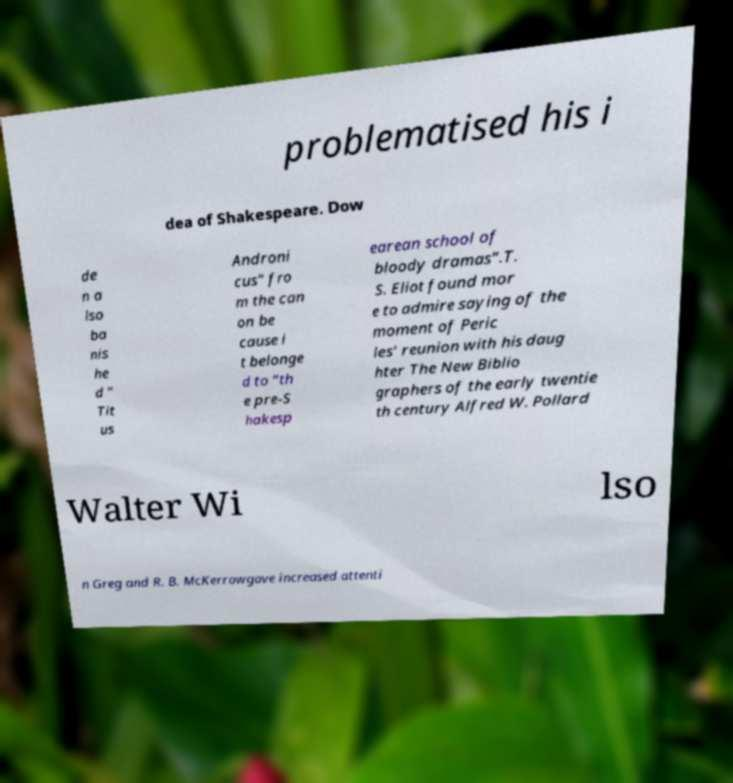Could you extract and type out the text from this image? problematised his i dea of Shakespeare. Dow de n a lso ba nis he d " Tit us Androni cus" fro m the can on be cause i t belonge d to “th e pre-S hakesp earean school of bloody dramas”.T. S. Eliot found mor e to admire saying of the moment of Peric les' reunion with his daug hter The New Biblio graphers of the early twentie th century Alfred W. Pollard Walter Wi lso n Greg and R. B. McKerrowgave increased attenti 